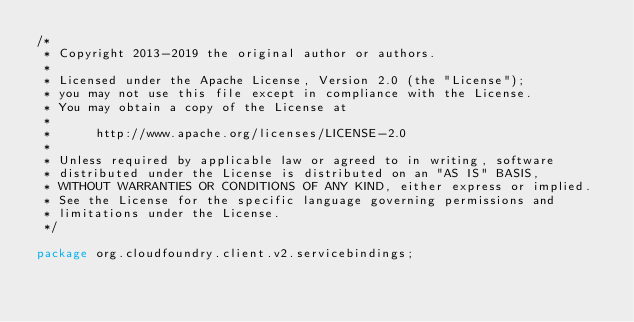<code> <loc_0><loc_0><loc_500><loc_500><_Java_>/*
 * Copyright 2013-2019 the original author or authors.
 *
 * Licensed under the Apache License, Version 2.0 (the "License");
 * you may not use this file except in compliance with the License.
 * You may obtain a copy of the License at
 *
 *      http://www.apache.org/licenses/LICENSE-2.0
 *
 * Unless required by applicable law or agreed to in writing, software
 * distributed under the License is distributed on an "AS IS" BASIS,
 * WITHOUT WARRANTIES OR CONDITIONS OF ANY KIND, either express or implied.
 * See the License for the specific language governing permissions and
 * limitations under the License.
 */

package org.cloudfoundry.client.v2.servicebindings;
</code> 